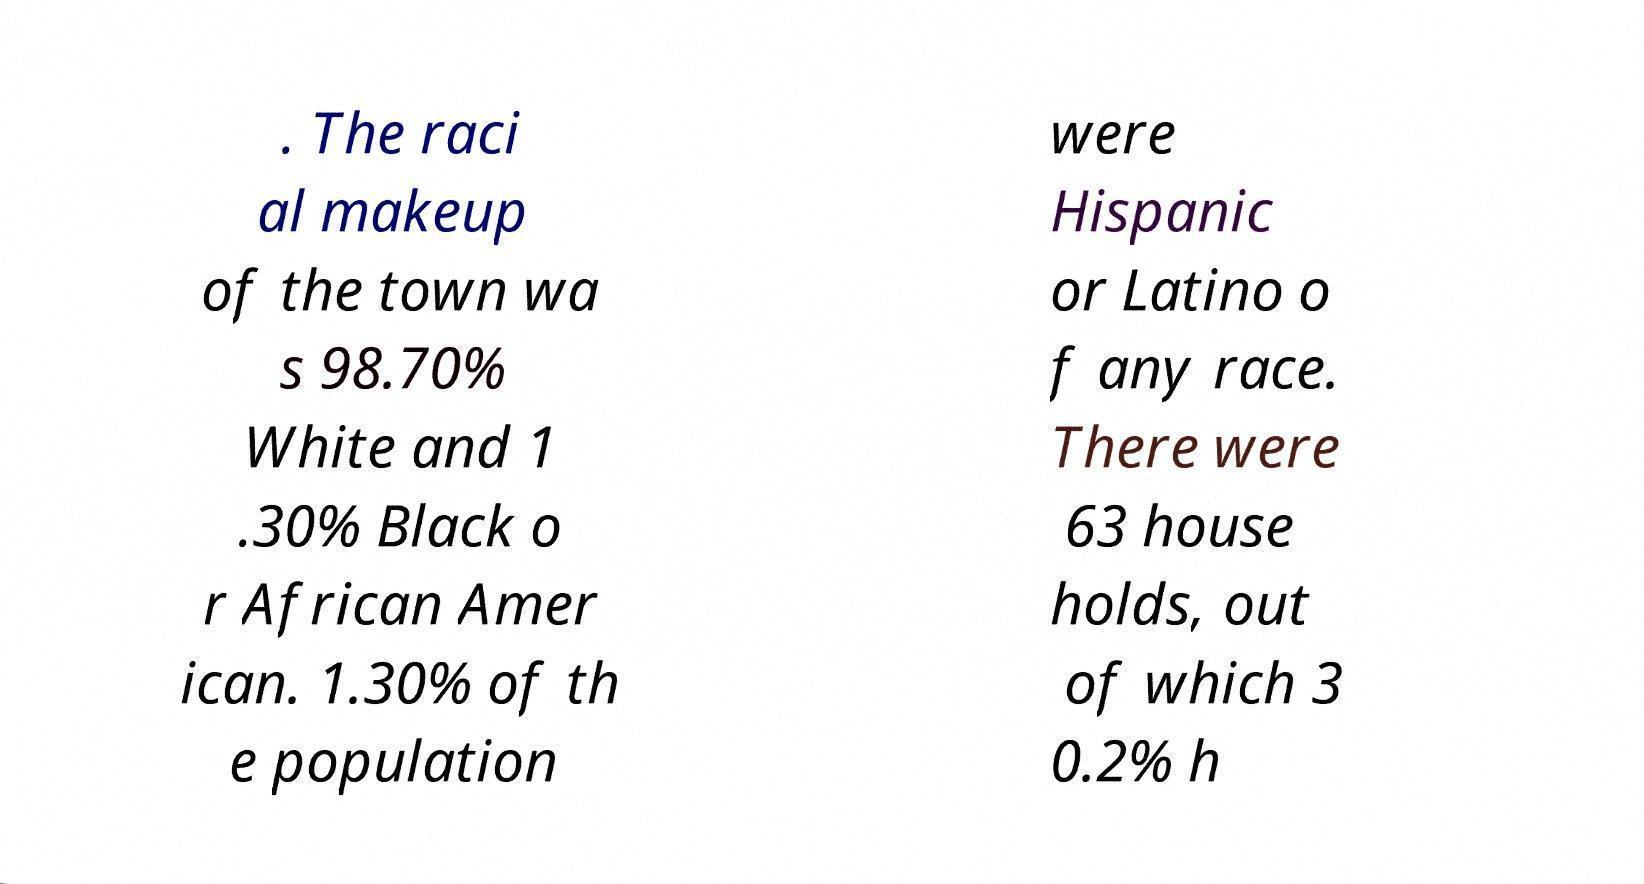Can you accurately transcribe the text from the provided image for me? . The raci al makeup of the town wa s 98.70% White and 1 .30% Black o r African Amer ican. 1.30% of th e population were Hispanic or Latino o f any race. There were 63 house holds, out of which 3 0.2% h 